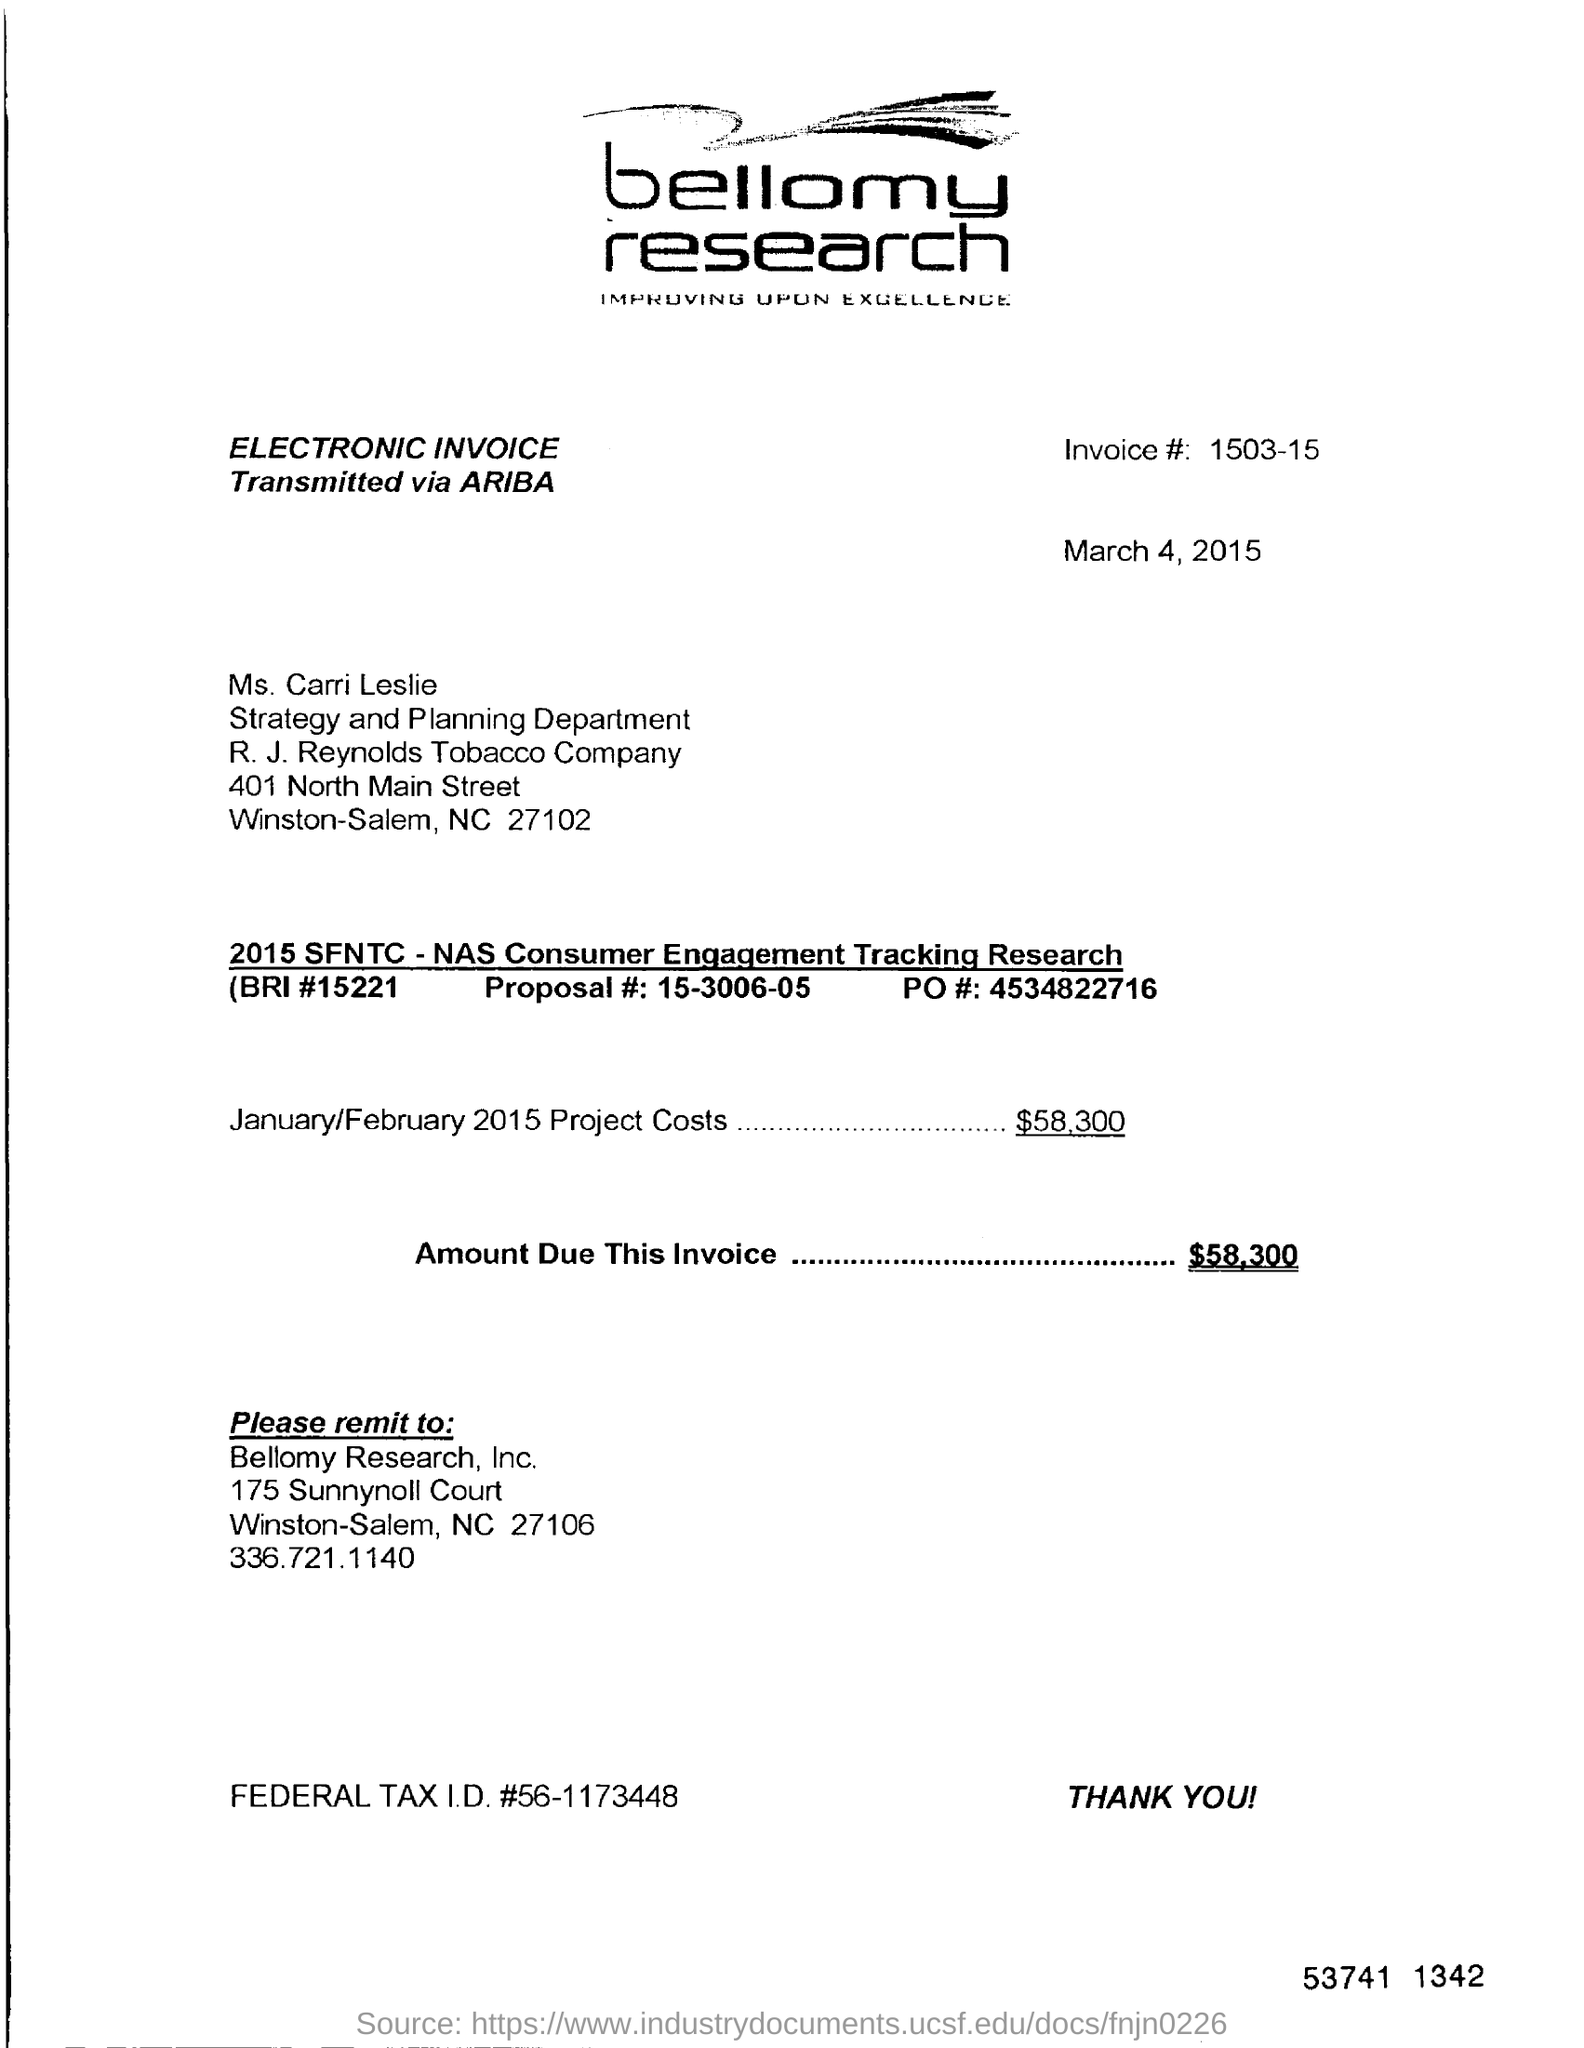Point out several critical features in this image. The project cost for the months of January and February in 2015 was $58,300. Bellomy Research, Inc. is the name of the company. The invoice code is 1503-15... The invoice mentions the department of Strategy and Planning. 